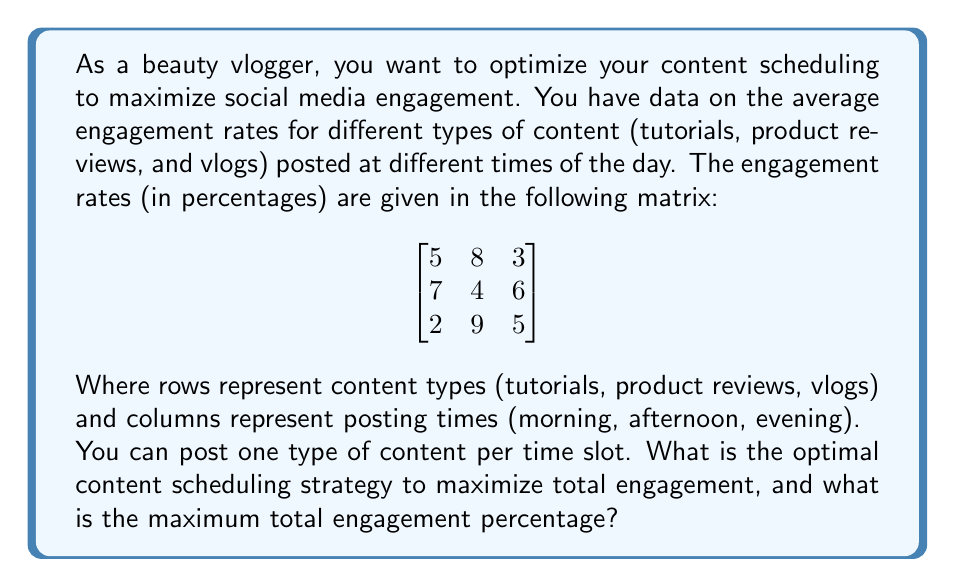What is the answer to this math problem? This problem can be solved using the Hungarian algorithm for assignment problems. We want to maximize the total engagement, so we'll first convert this to a minimization problem by subtracting each element from the maximum value in the matrix (9).

1. Convert to minimization problem:
   $$
   \begin{bmatrix}
   4 & 1 & 6 \\
   2 & 5 & 3 \\
   7 & 0 & 4
   \end{bmatrix}
   $$

2. Subtract the minimum value in each row:
   $$
   \begin{bmatrix}
   3 & 0 & 5 \\
   0 & 3 & 1 \\
   7 & 0 & 4
   \end{bmatrix}
   $$

3. Subtract the minimum value in each column:
   $$
   \begin{bmatrix}
   3 & 0 & 4 \\
   0 & 3 & 0 \\
   7 & 0 & 3
   \end{bmatrix}
   $$

4. Cover all zeros with the minimum number of lines:
   [asy]
   size(200);
   pen redpen = red+1;
   
   for(int i=0; i<3; ++i)
     for(int j=0; j<3; ++j)
       draw((i,j)--(i+1,j)--(i+1,j+1)--(i,j+1)--cycle);
   
   label("3", (0.5,2.5));
   label("0", (1.5,2.5));
   label("4", (2.5,2.5));
   label("0", (0.5,1.5));
   label("3", (1.5,1.5));
   label("0", (2.5,1.5));
   label("7", (0.5,0.5));
   label("0", (1.5,0.5));
   label("3", (2.5,0.5));
   
   draw((0,2)--(3,2), redpen);
   draw((0,1)--(3,1), redpen);
   draw((1,0)--(1,3), redpen);
   [/asy]

5. Three lines are needed, which equals the number of rows/columns, so we have the optimal assignment.

6. The optimal assignment is:
   - Tutorials: Afternoon (8% engagement)
   - Product reviews: Morning (7% engagement)
   - Vlogs: Evening (5% engagement)

7. Calculate the total engagement:
   $8\% + 7\% + 5\% = 20\%$
Answer: The optimal content scheduling strategy is to post tutorials in the afternoon, product reviews in the morning, and vlogs in the evening. The maximum total engagement percentage is 20%. 